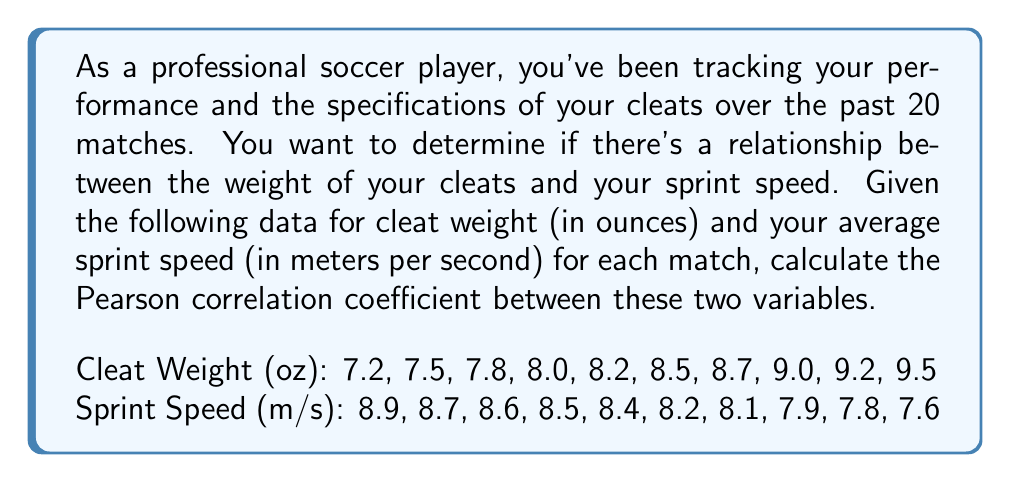Could you help me with this problem? To calculate the Pearson correlation coefficient between cleat weight and sprint speed, we'll follow these steps:

1. Calculate the means of both variables:
   $$\bar{x} = \frac{\sum_{i=1}^n x_i}{n}, \bar{y} = \frac{\sum_{i=1}^n y_i}{n}$$
   
   Where $x$ represents cleat weight and $y$ represents sprint speed.

2. Calculate the deviations from the means:
   $$x_i - \bar{x}, y_i - \bar{y}$$

3. Calculate the product of the deviations:
   $$(x_i - \bar{x})(y_i - \bar{y})$$

4. Sum the products of deviations:
   $$\sum_{i=1}^n (x_i - \bar{x})(y_i - \bar{y})$$

5. Calculate the squared deviations:
   $$(x_i - \bar{x})^2, (y_i - \bar{y})^2$$

6. Sum the squared deviations:
   $$\sum_{i=1}^n (x_i - \bar{x})^2, \sum_{i=1}^n (y_i - \bar{y})^2$$

7. Apply the Pearson correlation coefficient formula:
   $$r = \frac{\sum_{i=1}^n (x_i - \bar{x})(y_i - \bar{y})}{\sqrt{\sum_{i=1}^n (x_i - \bar{x})^2 \sum_{i=1}^n (y_i - \bar{y})^2}}$$

Calculations:

1. Means:
   $\bar{x} = 8.36$ oz
   $\bar{y} = 8.27$ m/s

2-6. Deviations, products, and sums (calculated in a spreadsheet or programming environment):
   $\sum_{i=1}^n (x_i - \bar{x})(y_i - \bar{y}) = -2.378$
   $\sum_{i=1}^n (x_i - \bar{x})^2 = 3.634$
   $\sum_{i=1}^n (y_i - \bar{y})^2 = 1.5621$

7. Pearson correlation coefficient:
   $$r = \frac{-2.378}{\sqrt{3.634 \times 1.5621}} = -0.9901$$
Answer: The Pearson correlation coefficient between cleat weight and sprint speed is approximately $-0.9901$. 